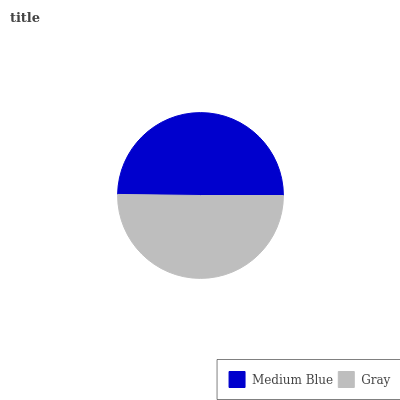Is Medium Blue the minimum?
Answer yes or no. Yes. Is Gray the maximum?
Answer yes or no. Yes. Is Gray the minimum?
Answer yes or no. No. Is Gray greater than Medium Blue?
Answer yes or no. Yes. Is Medium Blue less than Gray?
Answer yes or no. Yes. Is Medium Blue greater than Gray?
Answer yes or no. No. Is Gray less than Medium Blue?
Answer yes or no. No. Is Gray the high median?
Answer yes or no. Yes. Is Medium Blue the low median?
Answer yes or no. Yes. Is Medium Blue the high median?
Answer yes or no. No. Is Gray the low median?
Answer yes or no. No. 